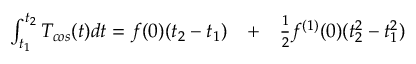Convert formula to latex. <formula><loc_0><loc_0><loc_500><loc_500>\begin{array} { r l r } { \int _ { t _ { 1 } } ^ { t _ { 2 } } T _ { \cos } ( t ) d t = f ( 0 ) ( t _ { 2 } - t _ { 1 } ) } & + } & { \frac { 1 } { 2 } f ^ { ( 1 ) } ( 0 ) ( t _ { 2 } ^ { 2 } - t _ { 1 } ^ { 2 } ) } \end{array}</formula> 